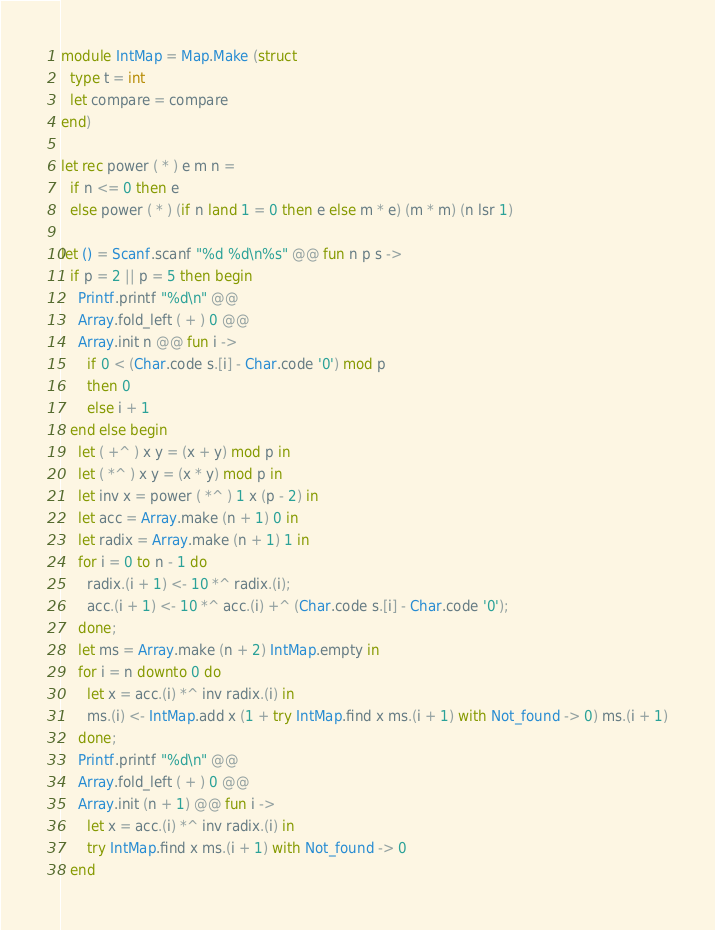<code> <loc_0><loc_0><loc_500><loc_500><_OCaml_>module IntMap = Map.Make (struct
  type t = int
  let compare = compare
end)

let rec power ( * ) e m n =
  if n <= 0 then e
  else power ( * ) (if n land 1 = 0 then e else m * e) (m * m) (n lsr 1)

let () = Scanf.scanf "%d %d\n%s" @@ fun n p s ->
  if p = 2 || p = 5 then begin
    Printf.printf "%d\n" @@
    Array.fold_left ( + ) 0 @@
    Array.init n @@ fun i ->
      if 0 < (Char.code s.[i] - Char.code '0') mod p
      then 0
      else i + 1
  end else begin
    let ( +^ ) x y = (x + y) mod p in
    let ( *^ ) x y = (x * y) mod p in
    let inv x = power ( *^ ) 1 x (p - 2) in
    let acc = Array.make (n + 1) 0 in
    let radix = Array.make (n + 1) 1 in
    for i = 0 to n - 1 do
      radix.(i + 1) <- 10 *^ radix.(i);
      acc.(i + 1) <- 10 *^ acc.(i) +^ (Char.code s.[i] - Char.code '0');
    done;
    let ms = Array.make (n + 2) IntMap.empty in
    for i = n downto 0 do
      let x = acc.(i) *^ inv radix.(i) in
      ms.(i) <- IntMap.add x (1 + try IntMap.find x ms.(i + 1) with Not_found -> 0) ms.(i + 1)
    done;
    Printf.printf "%d\n" @@
    Array.fold_left ( + ) 0 @@
    Array.init (n + 1) @@ fun i ->
      let x = acc.(i) *^ inv radix.(i) in
      try IntMap.find x ms.(i + 1) with Not_found -> 0
  end</code> 